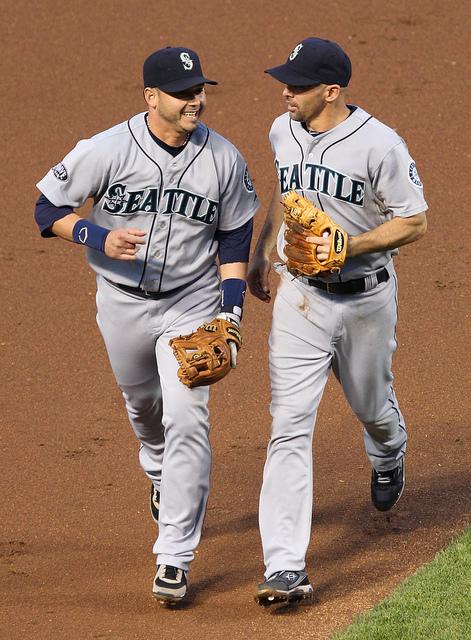What state is Seattle in?
Concise answer only. Washington. What color are the player on right's gloves?
Answer briefly. Brown. What team do they play for?
Concise answer only. Seattle. Are they both from the same team?
Be succinct. Yes. What state does this team come from?
Keep it brief. Washington. Are these players on the same team?
Be succinct. Yes. 